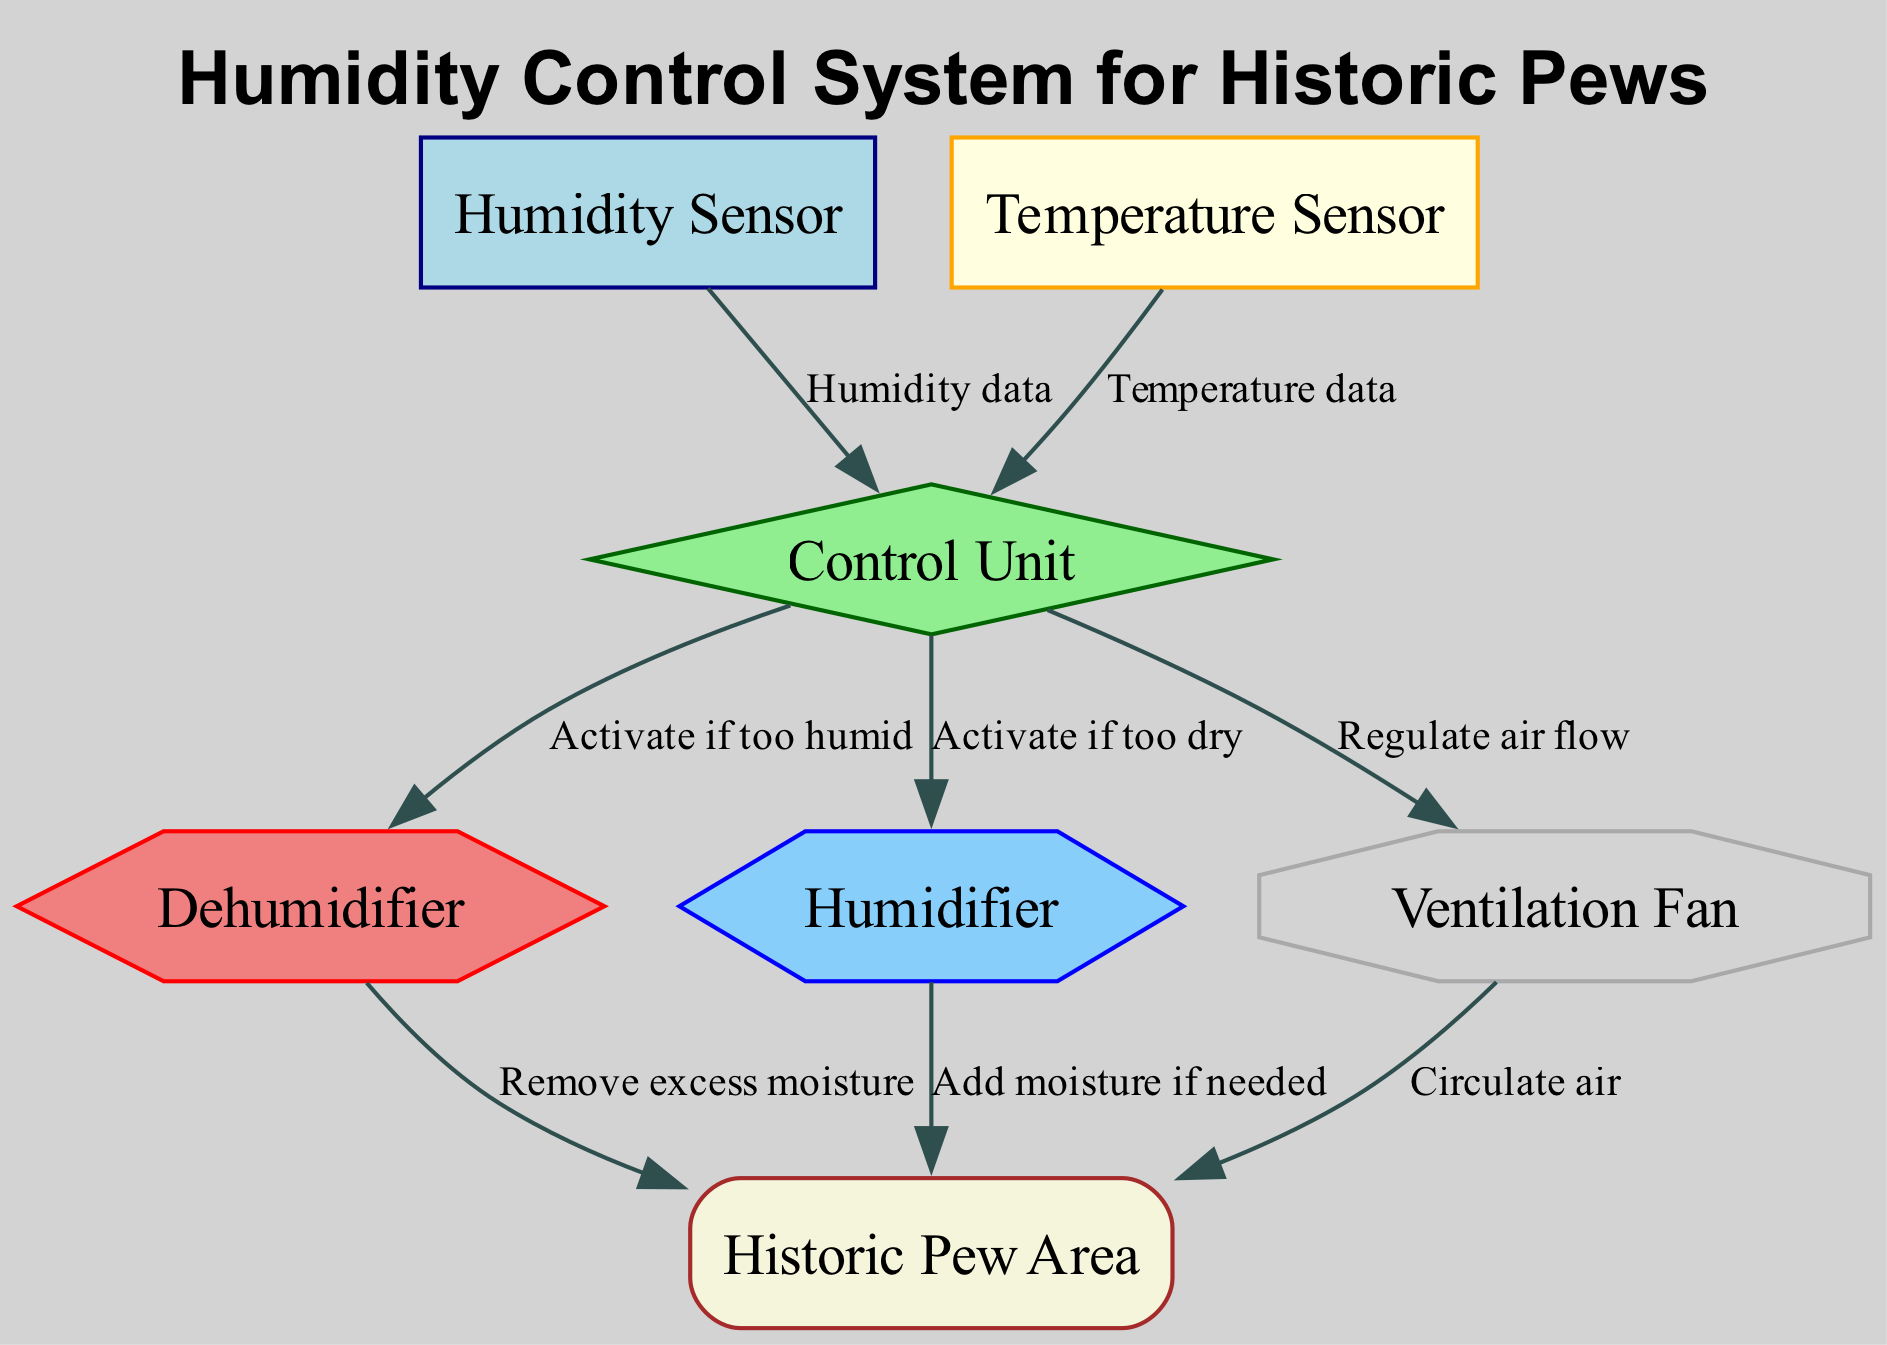what is the total number of nodes in the diagram? The diagram includes nodes for the humidity sensor, temperature sensor, control unit, dehumidifier, humidifier, ventilation fan, and pew area. Adding these nodes gives a total of seven.
Answer: 7 which component receives humidity data? The humidity sensor is connected to the control unit and provides humidity data directly to it, as indicated by the edge labeled "Humidity data."
Answer: control unit what is the shape of the control unit node? The control unit is represented in the diagram as a diamond shape. This is specified in the node styles for the control unit.
Answer: diamond which component activates the humidifier? The control unit is responsible for activating the humidifier if the environment is too dry. This is indicated by the edge labeled "Activate if too dry" connecting them.
Answer: control unit how many edges are connected to the pew area? The pew area has three edges connected to it from the dehumidifier, humidifier, and ventilation fan. This is based on the connections that flow into the pew area from these components.
Answer: 3 if the humidity level is too dry, which device is triggered? If the humidity level is determined to be too dry, the control unit activates the humidifier to add moisture, as specified in the edge label.
Answer: humidifier what does the dehumidifier do according to the diagram? The edge labeled "Remove excess moisture" indicates that the dehumidifier's function is to eliminate extra moisture from the pew area.
Answer: remove excess moisture what type of sensor is used alongside the humidity sensor? The diagram includes a temperature sensor in addition to the humidity sensor, as shown by the two sensors connected to the control unit.
Answer: temperature sensor what is the purpose of the ventilation fan in the system? The ventilation fan regulates air flow to the pew area, as indicated by the edge labeled "Regulate air flow" connecting the control unit to the ventilation fan.
Answer: regulate air flow 